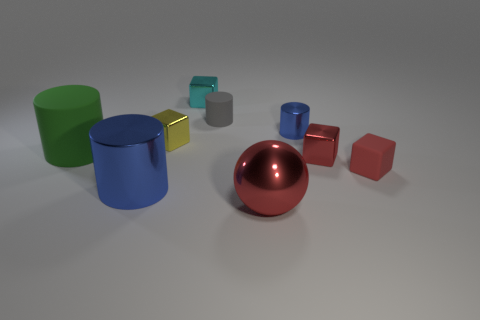Add 1 tiny metal blocks. How many objects exist? 10 Subtract all balls. How many objects are left? 8 Add 7 spheres. How many spheres are left? 8 Add 9 tiny rubber blocks. How many tiny rubber blocks exist? 10 Subtract 0 gray spheres. How many objects are left? 9 Subtract all blue metallic objects. Subtract all tiny metallic cylinders. How many objects are left? 6 